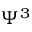Convert formula to latex. <formula><loc_0><loc_0><loc_500><loc_500>\Psi ^ { 3 }</formula> 